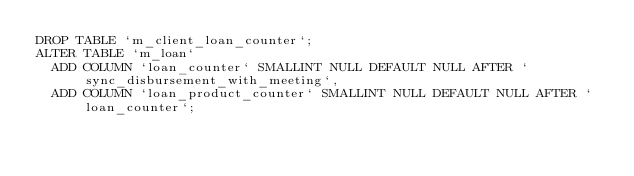Convert code to text. <code><loc_0><loc_0><loc_500><loc_500><_SQL_>DROP TABLE `m_client_loan_counter`;
ALTER TABLE `m_loan`
	ADD COLUMN `loan_counter` SMALLINT NULL DEFAULT NULL AFTER `sync_disbursement_with_meeting`,
	ADD COLUMN `loan_product_counter` SMALLINT NULL DEFAULT NULL AFTER `loan_counter`;
</code> 